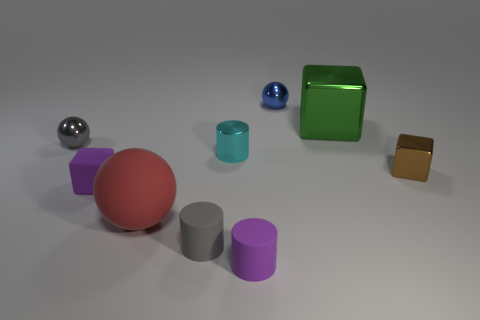Add 1 large brown metal spheres. How many objects exist? 10 Subtract all cubes. How many objects are left? 6 Add 9 tiny gray rubber balls. How many tiny gray rubber balls exist? 9 Subtract 0 brown cylinders. How many objects are left? 9 Subtract all blue spheres. Subtract all tiny shiny cylinders. How many objects are left? 7 Add 9 big shiny objects. How many big shiny objects are left? 10 